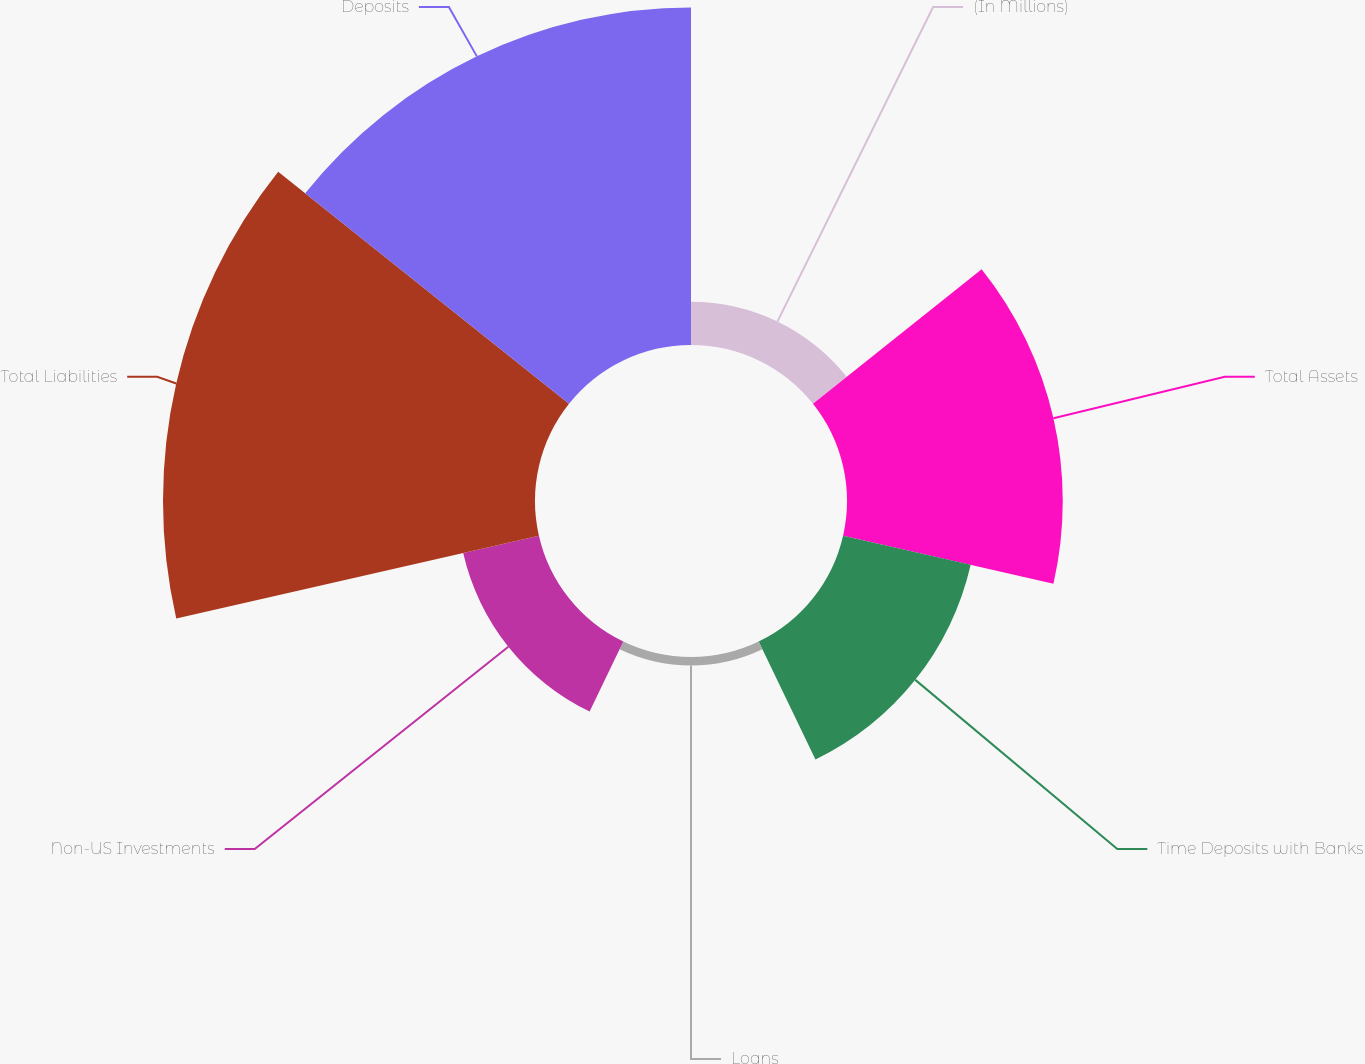Convert chart. <chart><loc_0><loc_0><loc_500><loc_500><pie_chart><fcel>(In Millions)<fcel>Total Assets<fcel>Time Deposits with Banks<fcel>Loans<fcel>Non-US Investments<fcel>Total Liabilities<fcel>Deposits<nl><fcel>3.64%<fcel>18.2%<fcel>11.04%<fcel>0.72%<fcel>6.55%<fcel>31.38%<fcel>28.47%<nl></chart> 